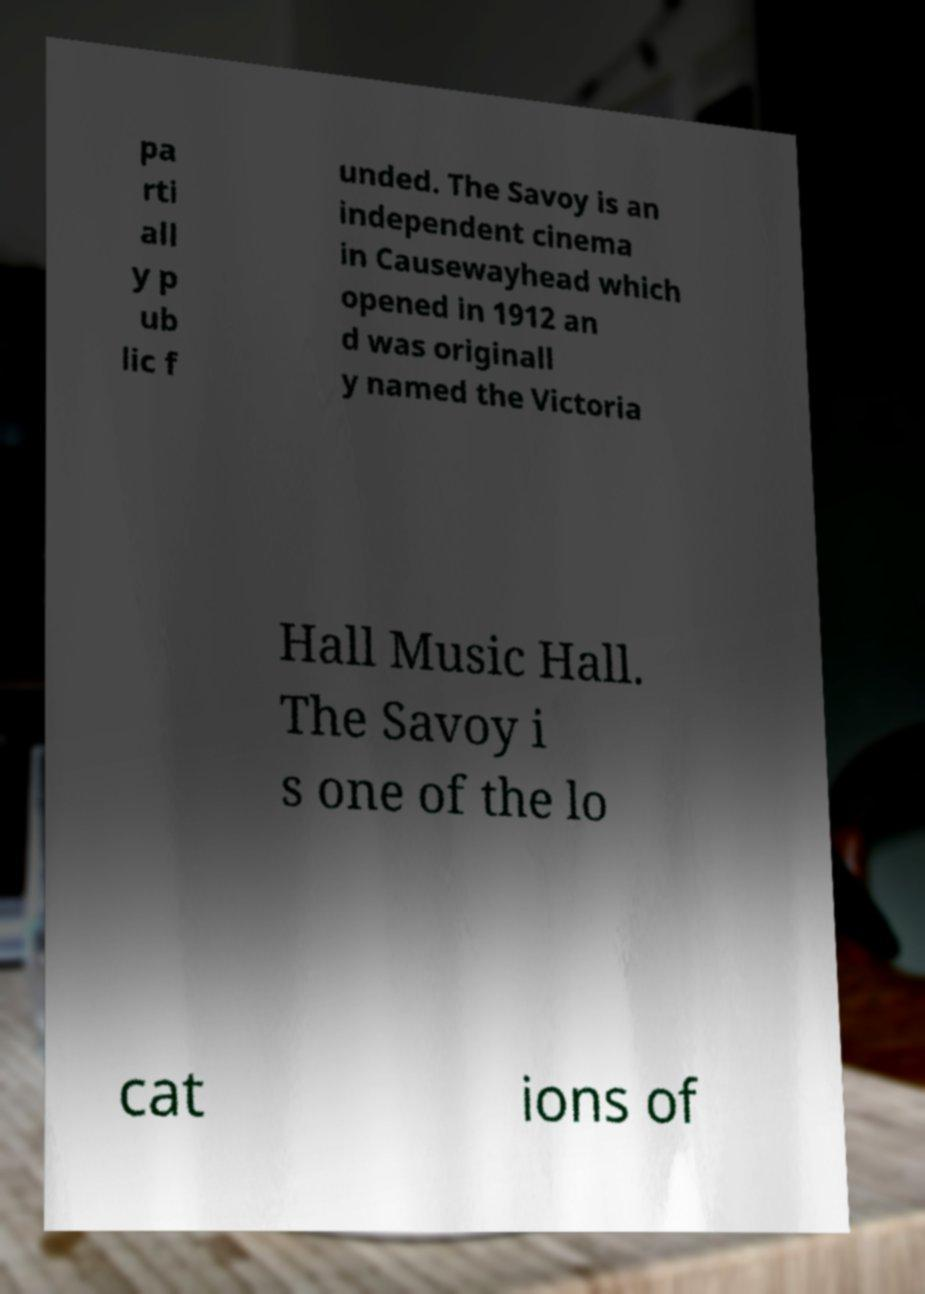Please identify and transcribe the text found in this image. pa rti all y p ub lic f unded. The Savoy is an independent cinema in Causewayhead which opened in 1912 an d was originall y named the Victoria Hall Music Hall. The Savoy i s one of the lo cat ions of 